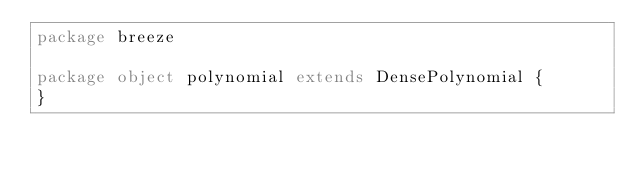<code> <loc_0><loc_0><loc_500><loc_500><_Scala_>package breeze

package object polynomial extends DensePolynomial {
}
</code> 